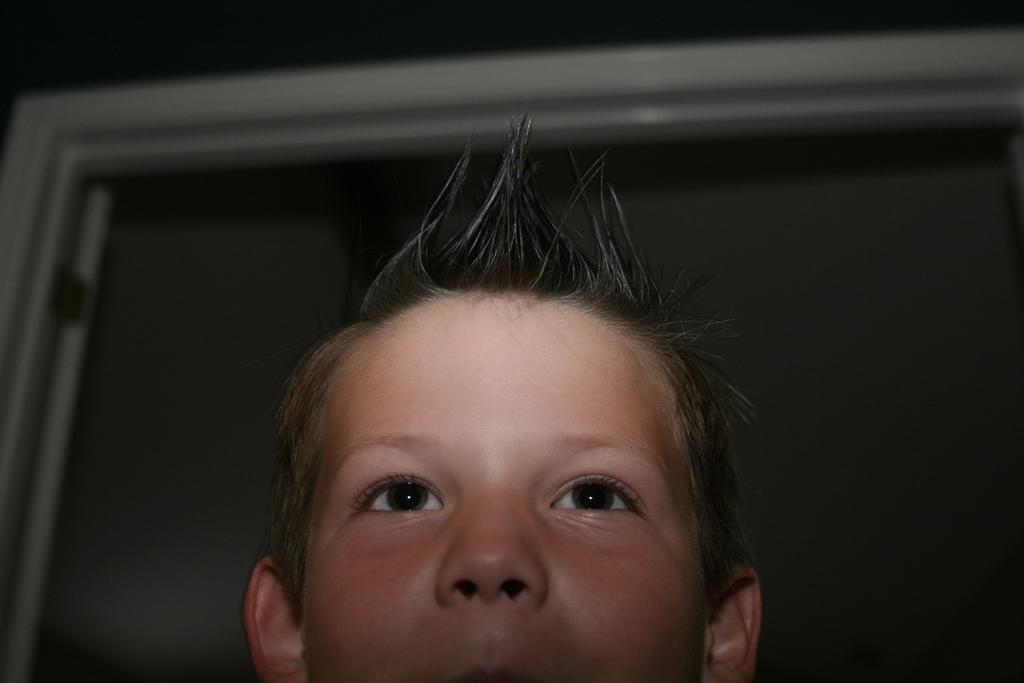Who is present in the image? There is a boy in the image. What can be seen in the background of the image? There is a door in the background of the image. Can you see the boy's body in the image? The term "body" is not mentioned in the provided facts, but the boy is present in the image. Is there a rabbit in the image? There is no mention of a rabbit in the provided facts, so it cannot be determined from the image. 